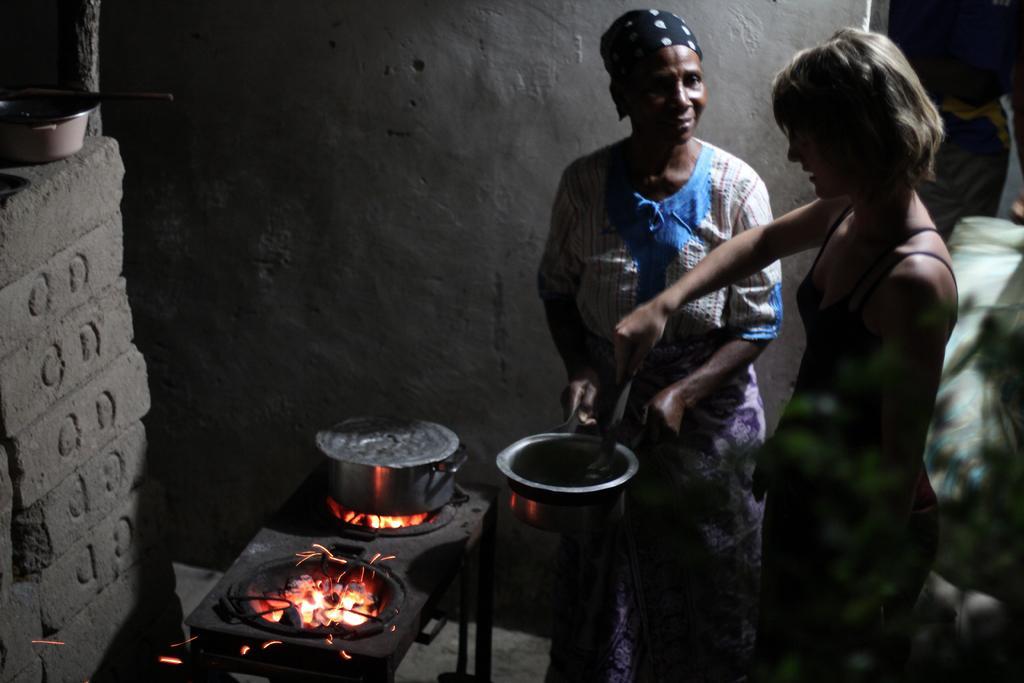Describe this image in one or two sentences. Here there are two women standing on the floor. Among them one is holding bowl and the other is holding spoon in her hand. In the background there is a vessel on a stove,wall and on the left there are bricks and a bowl on it. 